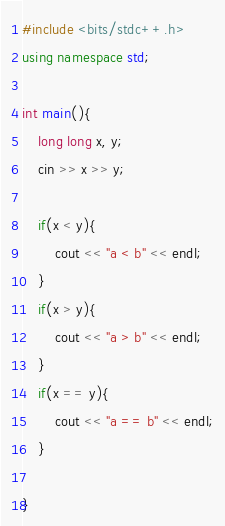Convert code to text. <code><loc_0><loc_0><loc_500><loc_500><_C++_>#include <bits/stdc++.h>
using namespace std;
 
int main(){
    long long x, y;
    cin >> x >> y;

    if(x < y){
        cout << "a < b" << endl;
    }
    if(x > y){
        cout << "a > b" << endl;
    }
    if(x == y){
        cout << "a == b" << endl;
    }

}
</code> 